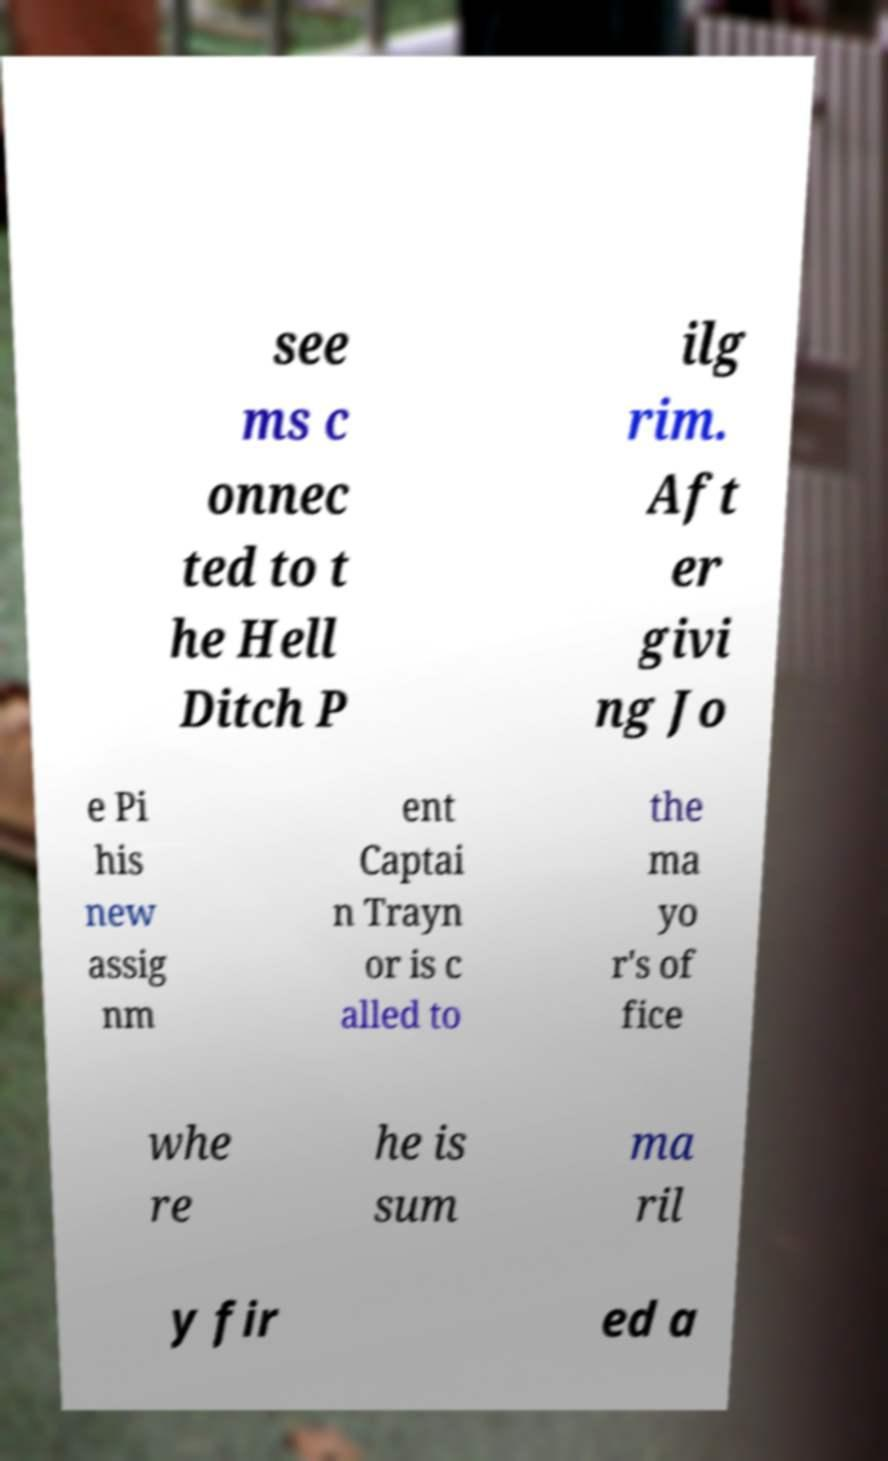What messages or text are displayed in this image? I need them in a readable, typed format. see ms c onnec ted to t he Hell Ditch P ilg rim. Aft er givi ng Jo e Pi his new assig nm ent Captai n Trayn or is c alled to the ma yo r's of fice whe re he is sum ma ril y fir ed a 